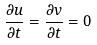<formula> <loc_0><loc_0><loc_500><loc_500>\frac { \partial u } { \partial t } = \frac { \partial v } { \partial t } = 0</formula> 